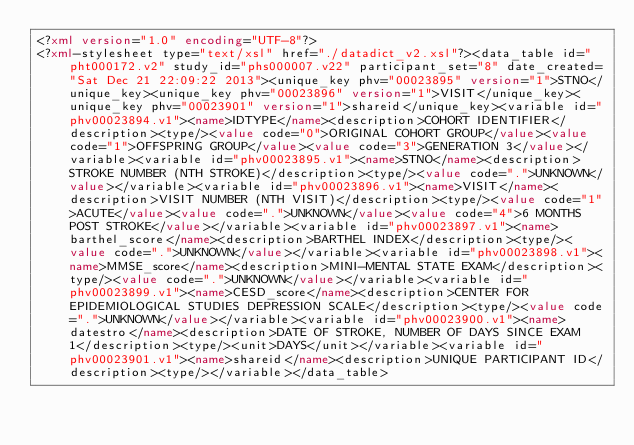<code> <loc_0><loc_0><loc_500><loc_500><_XML_><?xml version="1.0" encoding="UTF-8"?>
<?xml-stylesheet type="text/xsl" href="./datadict_v2.xsl"?><data_table id="pht000172.v2" study_id="phs000007.v22" participant_set="8" date_created="Sat Dec 21 22:09:22 2013"><unique_key phv="00023895" version="1">STNO</unique_key><unique_key phv="00023896" version="1">VISIT</unique_key><unique_key phv="00023901" version="1">shareid</unique_key><variable id="phv00023894.v1"><name>IDTYPE</name><description>COHORT IDENTIFIER</description><type/><value code="0">ORIGINAL COHORT GROUP</value><value code="1">OFFSPRING GROUP</value><value code="3">GENERATION 3</value></variable><variable id="phv00023895.v1"><name>STNO</name><description>STROKE NUMBER (NTH STROKE)</description><type/><value code=".">UNKNOWN</value></variable><variable id="phv00023896.v1"><name>VISIT</name><description>VISIT NUMBER (NTH VISIT)</description><type/><value code="1">ACUTE</value><value code=".">UNKNOWN</value><value code="4">6 MONTHS POST STROKE</value></variable><variable id="phv00023897.v1"><name>barthel_score</name><description>BARTHEL INDEX</description><type/><value code=".">UNKNOWN</value></variable><variable id="phv00023898.v1"><name>MMSE_score</name><description>MINI-MENTAL STATE EXAM</description><type/><value code=".">UNKNOWN</value></variable><variable id="phv00023899.v1"><name>CESD_score</name><description>CENTER FOR EPIDEMIOLOGICAL STUDIES DEPRESSION SCALE</description><type/><value code=".">UNKNOWN</value></variable><variable id="phv00023900.v1"><name>datestro</name><description>DATE OF STROKE, NUMBER OF DAYS SINCE EXAM 1</description><type/><unit>DAYS</unit></variable><variable id="phv00023901.v1"><name>shareid</name><description>UNIQUE PARTICIPANT ID</description><type/></variable></data_table>
</code> 